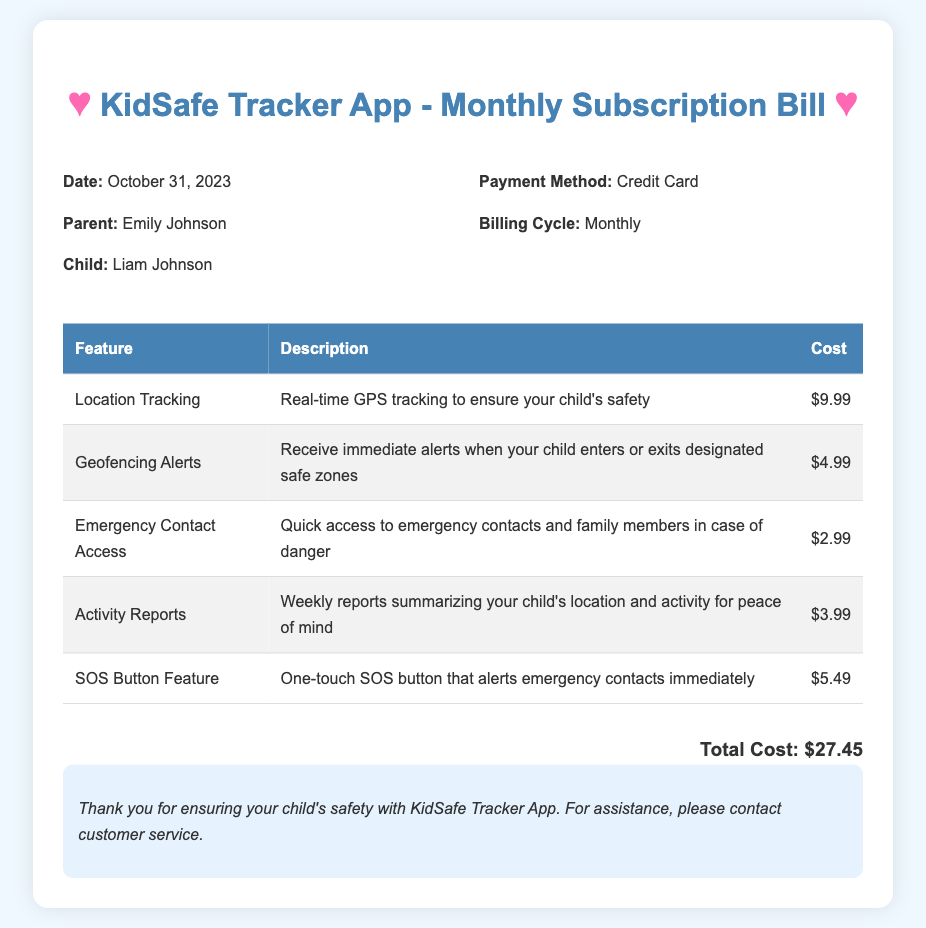What is the date of the bill? The date is specified in the document as October 31, 2023.
Answer: October 31, 2023 Who is the parent listed on the bill? The parent name is mentioned in the bill as Emily Johnson.
Answer: Emily Johnson What is the total cost of the subscription? The total cost is provided at the bottom of the document, which adds up all the features used.
Answer: $27.45 How many features are billed this month? There are five features listed in the table of the bill.
Answer: 5 What feature provides real-time GPS tracking? The feature specifically mentioned for real-time GPS tracking is Location Tracking.
Answer: Location Tracking What is the cost for the Geofencing Alerts feature? The cost for Geofencing Alerts is noted in the feature list of the document.
Answer: $4.99 Which payment method was used? The payment method is indicated in the bill as a Credit Card.
Answer: Credit Card What feature has an SOS button? The document indicates that the SOS Button Feature has an emergency alert function.
Answer: SOS Button Feature What does the Activity Reports feature provide? The description of the Activity Reports mentions summarizing the child's location and activities.
Answer: Weekly reports summarizing your child's location and activity 